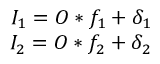<formula> <loc_0><loc_0><loc_500><loc_500>\begin{array} { r } { I _ { 1 } = O \ast f _ { 1 } + \delta _ { 1 } } \\ { I _ { 2 } = O \ast f _ { 2 } + \delta _ { 2 } } \end{array}</formula> 